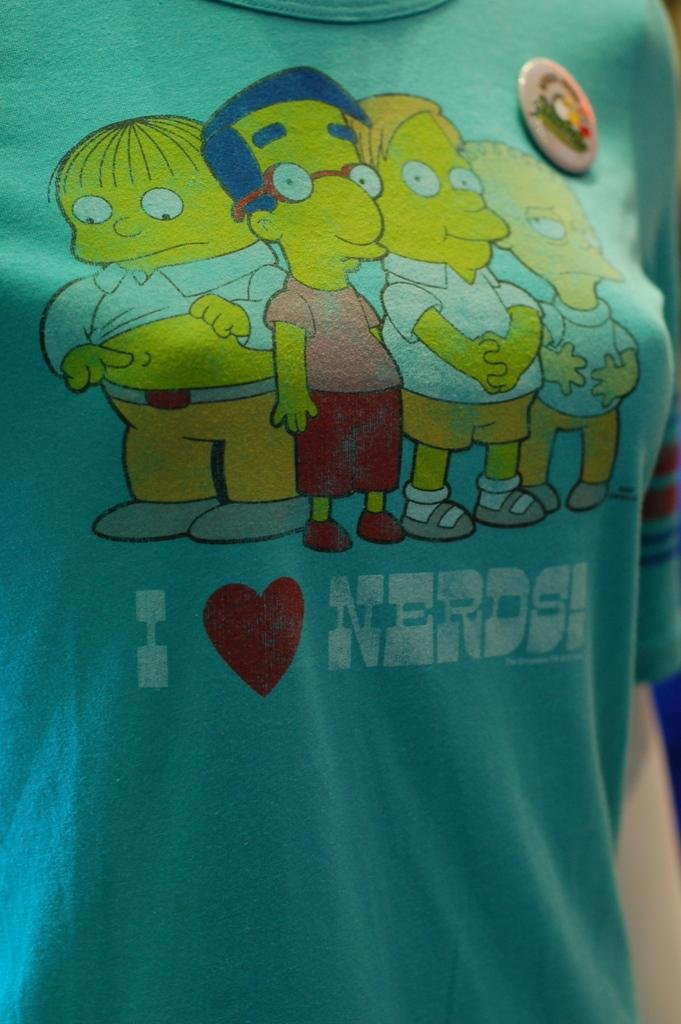What type of clothing item is in the image? There is a T-shirt in the image. What is featured on the T-shirt? The T-shirt has text and animated cartoons on it. How does the T-shirt maintain its balance in the image? The T-shirt does not need to maintain balance, as it is a static image and not an object in motion. 